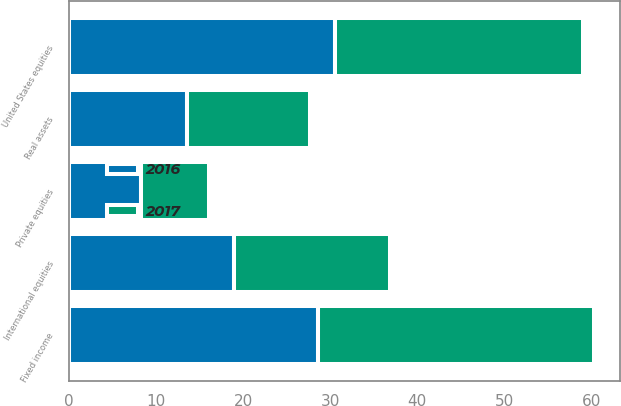Convert chart to OTSL. <chart><loc_0><loc_0><loc_500><loc_500><stacked_bar_chart><ecel><fcel>United States equities<fcel>International equities<fcel>Private equities<fcel>Fixed income<fcel>Real assets<nl><fcel>2017<fcel>28.5<fcel>17.9<fcel>7.8<fcel>31.7<fcel>14.1<nl><fcel>2016<fcel>30.5<fcel>19<fcel>8.3<fcel>28.6<fcel>13.6<nl></chart> 